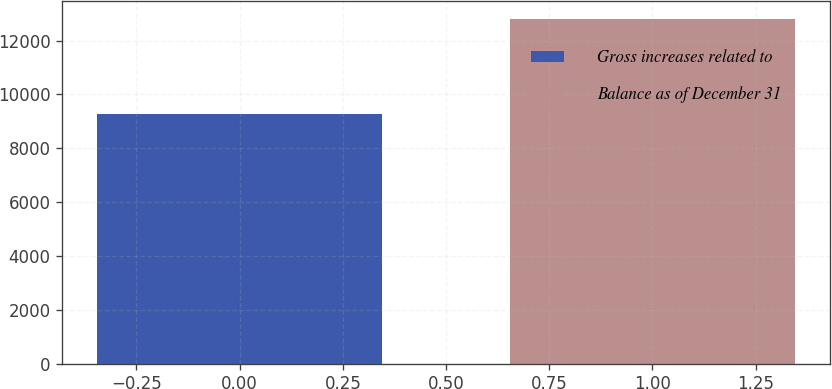Convert chart to OTSL. <chart><loc_0><loc_0><loc_500><loc_500><bar_chart><fcel>Gross increases related to<fcel>Balance as of December 31<nl><fcel>9269<fcel>12819<nl></chart> 